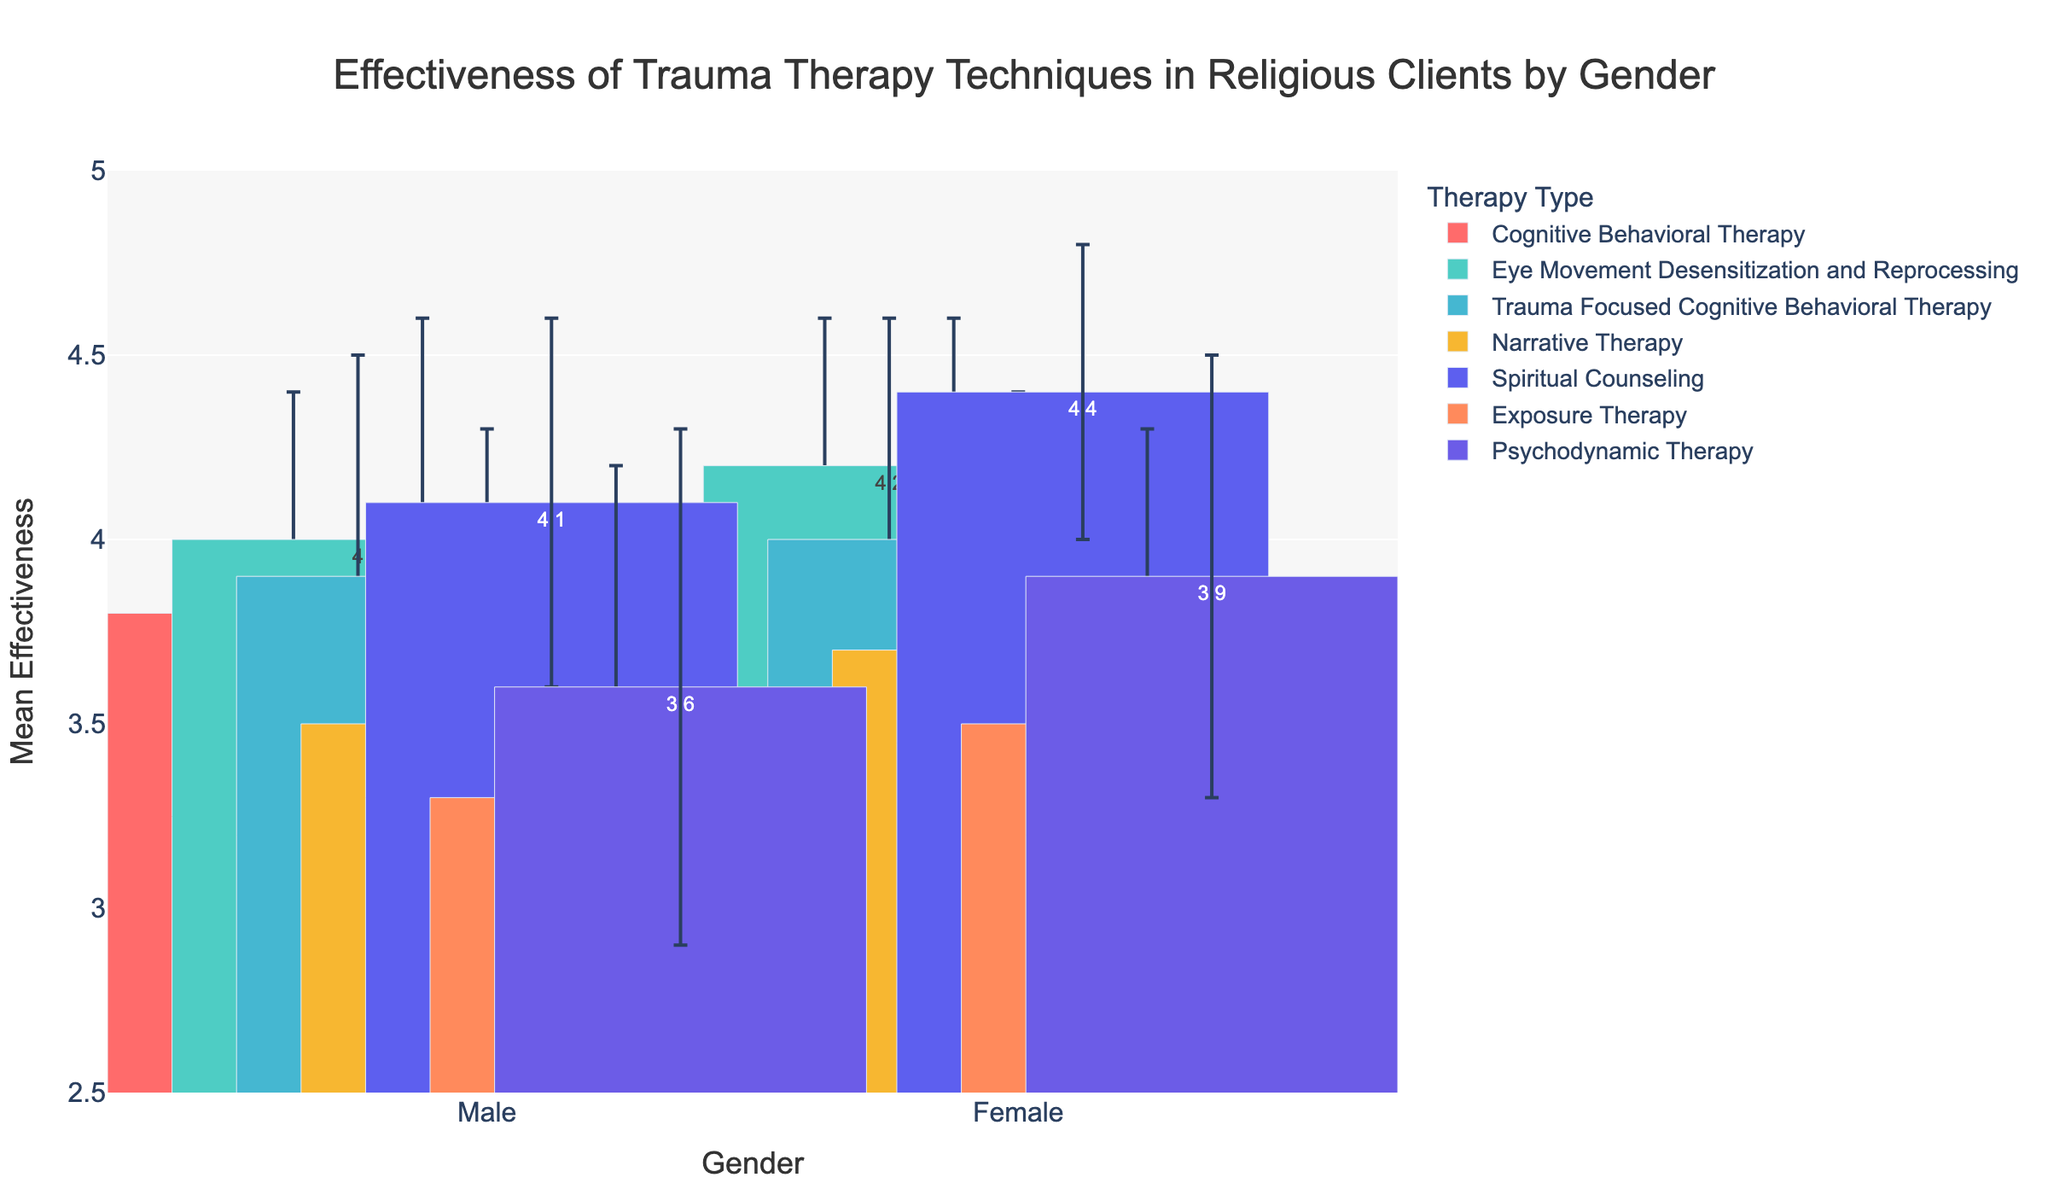What is the average effectiveness of Cognitive Behavioral Therapy in females? The Mean Effectiveness of Cognitive Behavioral Therapy in females is given directly in the plot.
Answer: 4.1 Which gender shows higher mean effectiveness for Eye Movement Desensitization and Reprocessing? Compare the Mean Effectiveness values for males and females for Eye Movement Desensitization and Reprocessing. Females have a higher value (4.2) compared to males (4.0).
Answer: Females What is the effectiveness range of Exposure Therapy for males? The Mean Effectiveness of Exposure Therapy for males is 3.3, with a Standard Deviation of 0.9. The range is calculated as Mean ± Standard Deviation: 3.3 ± 0.9, ranging between 2.4 and 4.2.
Answer: 2.4 to 4.2 Which therapy type shows the highest effectiveness in females? Find the highest Mean Effectiveness value for females across all therapy types. Spiritual Counseling has the highest value of 4.4.
Answer: Spiritual Counseling Between males and females, who has a higher average effectiveness for Spiritual Counseling? Compare the Mean Effectiveness values for males (4.1) and females (4.4) for Spiritual Counseling. Females show a higher value.
Answer: Females What is the effectiveness range of Narrative Therapy for females? The Mean Effectiveness of Narrative Therapy for females is 3.7, with a Standard Deviation of 0.7. The range is calculated as Mean ± Standard Deviation: 3.7 ± 0.7, ranging between 3.0 and 4.4.
Answer: 3.0 to 4.4 Which therapy type exhibits the least variability in effectiveness for males? Identify the therapy type with the smallest Standard Deviation for males. Eye Movement Desensitization and Reprocessing has the smallest Standard Deviation (0.5) among males.
Answer: Eye Movement Desensitization and Reprocessing For Trauma-Focused Cognitive Behavioral Therapy, by how much does the mean effectiveness differ between males and females? Subtract the Mean Effectiveness of males (3.9) from females (4.0) for Trauma-Focused Cognitive Behavioral Therapy: 4.0 - 3.9 = 0.1.
Answer: 0.1 Is there any therapy where males have a higher effectiveness than females? Compare Mean Effectiveness values of males with females across all therapy types. Males do not have a higher effectiveness than females in any therapy type shown.
Answer: No Among the listed therapies, which shows the largest effectiveness disparity between genders? Calculate the differences in Mean Effectiveness between genders for each therapy. Spiritual Counseling shows the largest disparity: 4.4 (females) - 4.1 (males) = 0.3.
Answer: Spiritual Counseling 